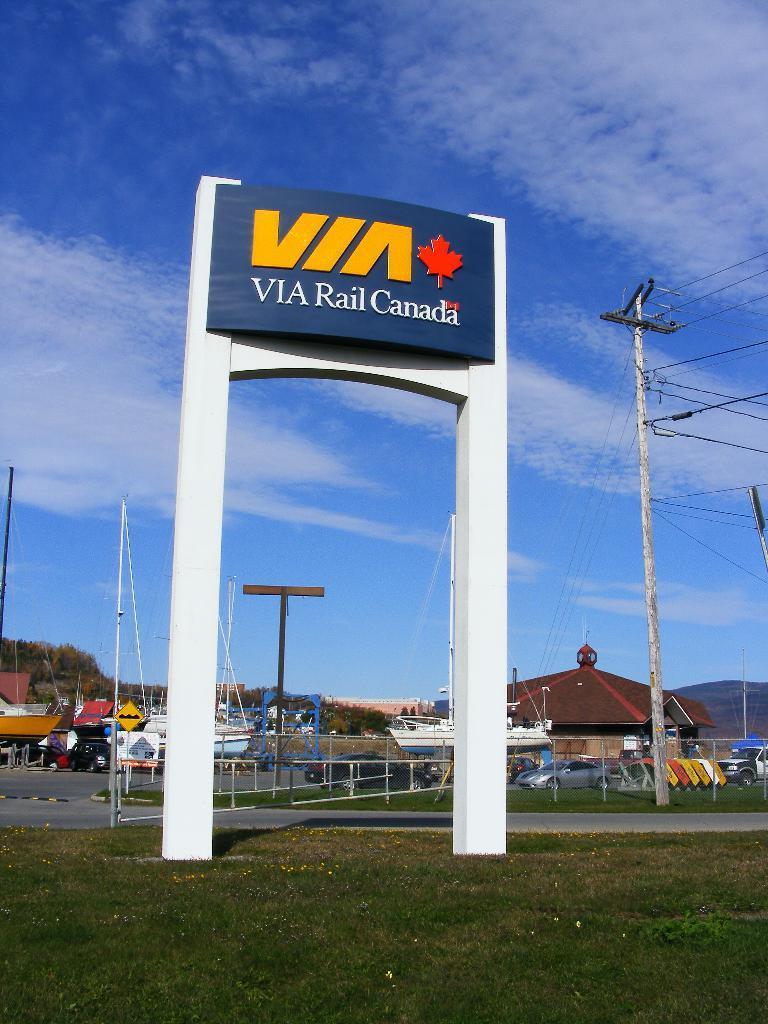Describe this image in one or two sentences. In the center the picture there is a hoarding. In the foreground there is grass. On the right there are cables and pole. In the center of the picture there are trees, buildings, vehicles, hoardings and poles. Sky is clear and it is sunny. 